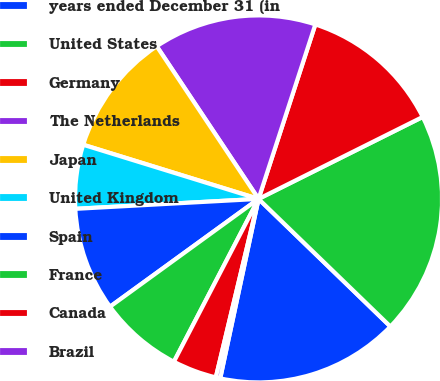Convert chart to OTSL. <chart><loc_0><loc_0><loc_500><loc_500><pie_chart><fcel>years ended December 31 (in<fcel>United States<fcel>Germany<fcel>The Netherlands<fcel>Japan<fcel>United Kingdom<fcel>Spain<fcel>France<fcel>Canada<fcel>Brazil<nl><fcel>16.11%<fcel>19.61%<fcel>12.62%<fcel>14.37%<fcel>10.87%<fcel>5.63%<fcel>9.13%<fcel>7.38%<fcel>3.89%<fcel>0.39%<nl></chart> 